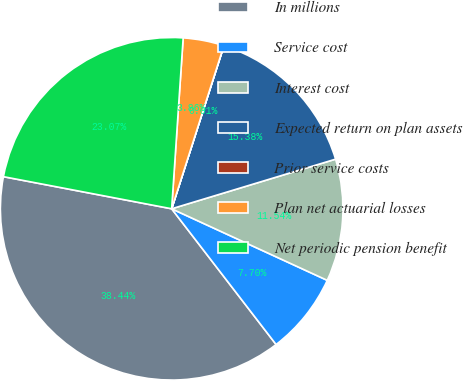<chart> <loc_0><loc_0><loc_500><loc_500><pie_chart><fcel>In millions<fcel>Service cost<fcel>Interest cost<fcel>Expected return on plan assets<fcel>Prior service costs<fcel>Plan net actuarial losses<fcel>Net periodic pension benefit<nl><fcel>38.44%<fcel>7.7%<fcel>11.54%<fcel>15.38%<fcel>0.01%<fcel>3.86%<fcel>23.07%<nl></chart> 